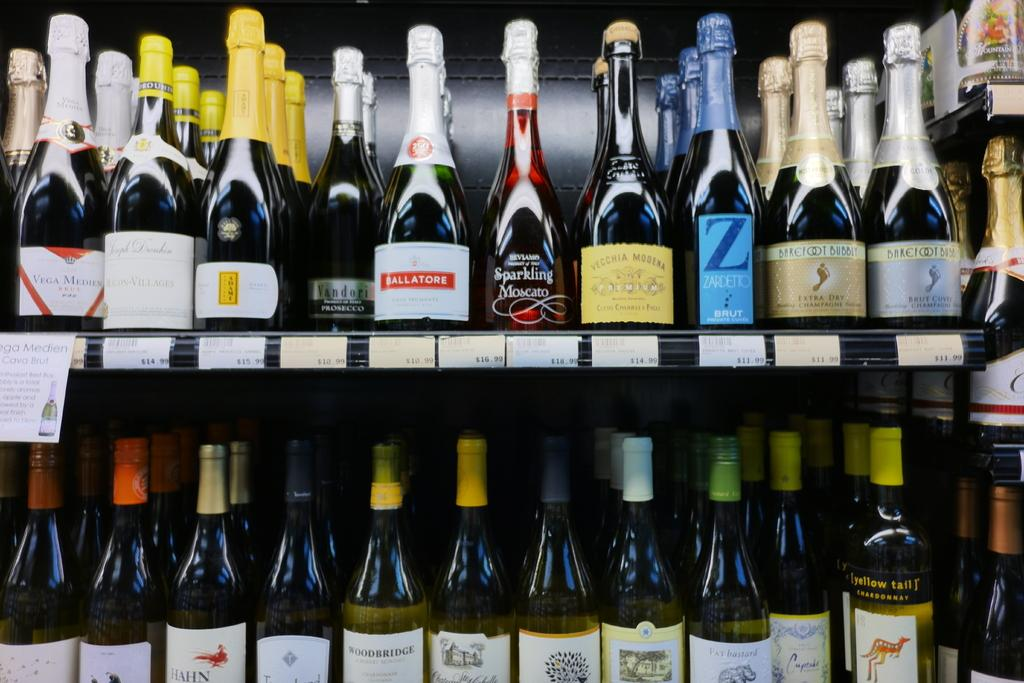<image>
Write a terse but informative summary of the picture. Various wine bottles on a store shelf including yellow tail brand. 